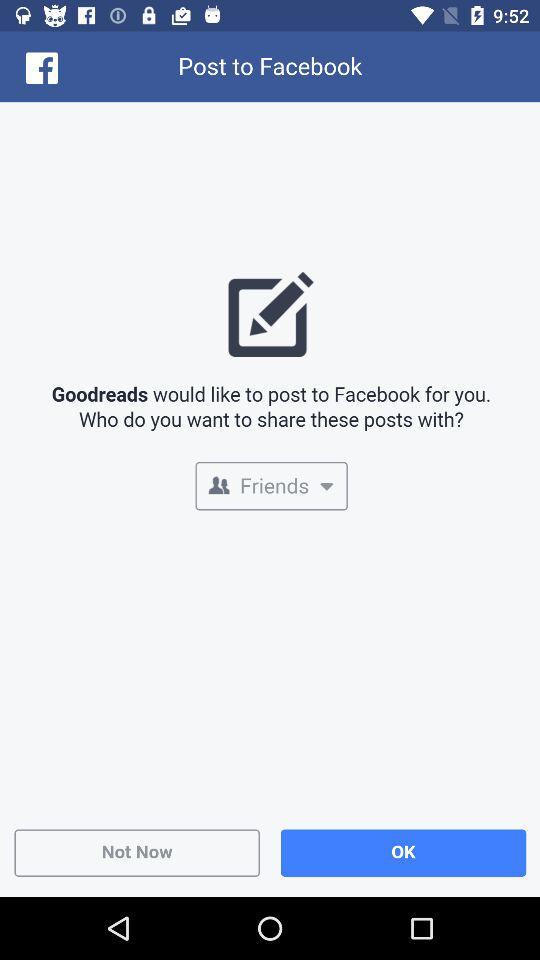What application is asking for permission? The application "Goodreads" is asking for permission. 